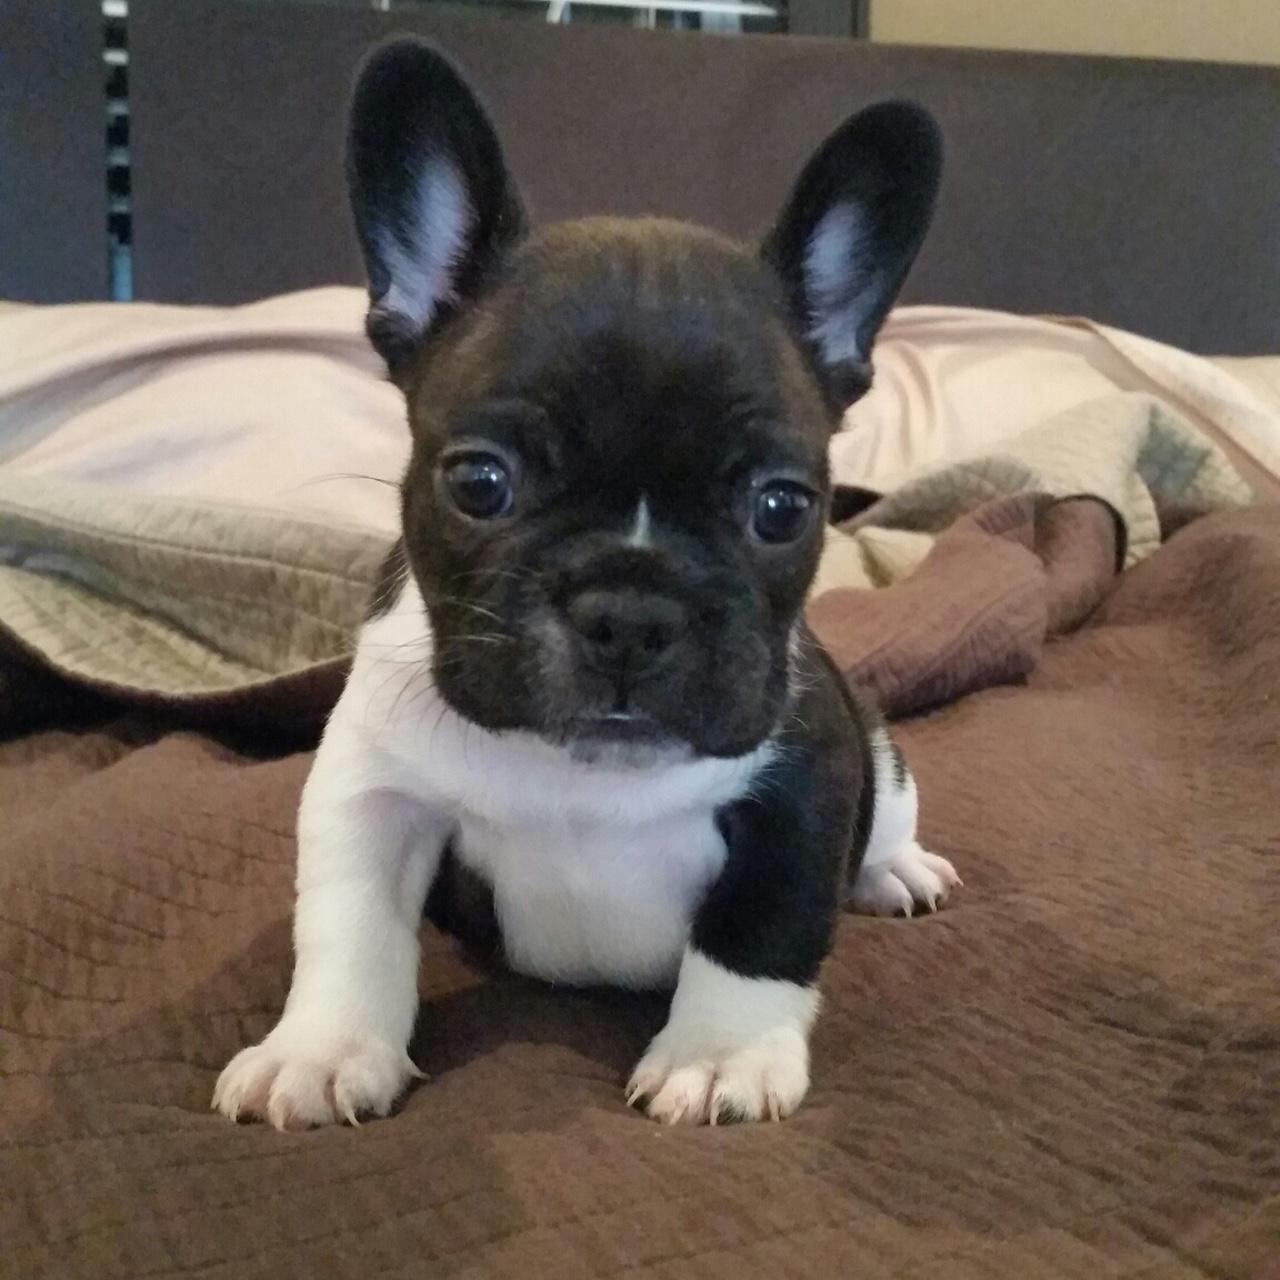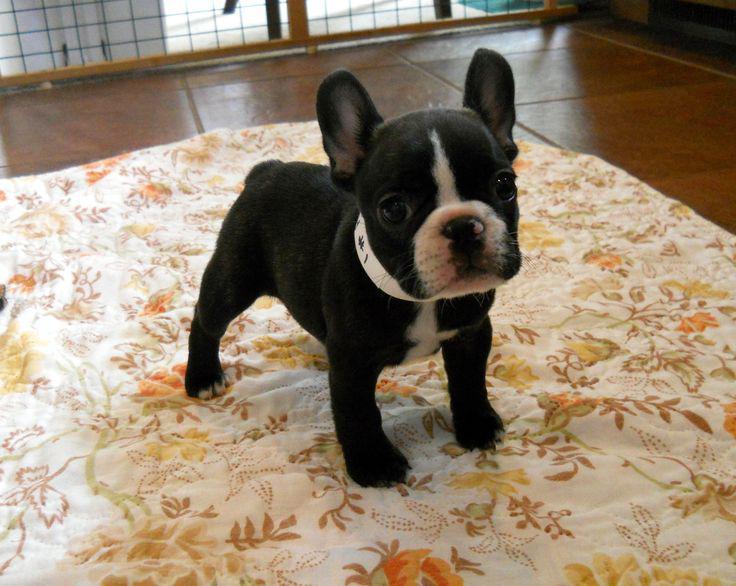The first image is the image on the left, the second image is the image on the right. Given the left and right images, does the statement "There is more than one dog in the right image." hold true? Answer yes or no. No. The first image is the image on the left, the second image is the image on the right. For the images displayed, is the sentence "Each image contains exactly one dog, and each has black and white markings." factually correct? Answer yes or no. Yes. 